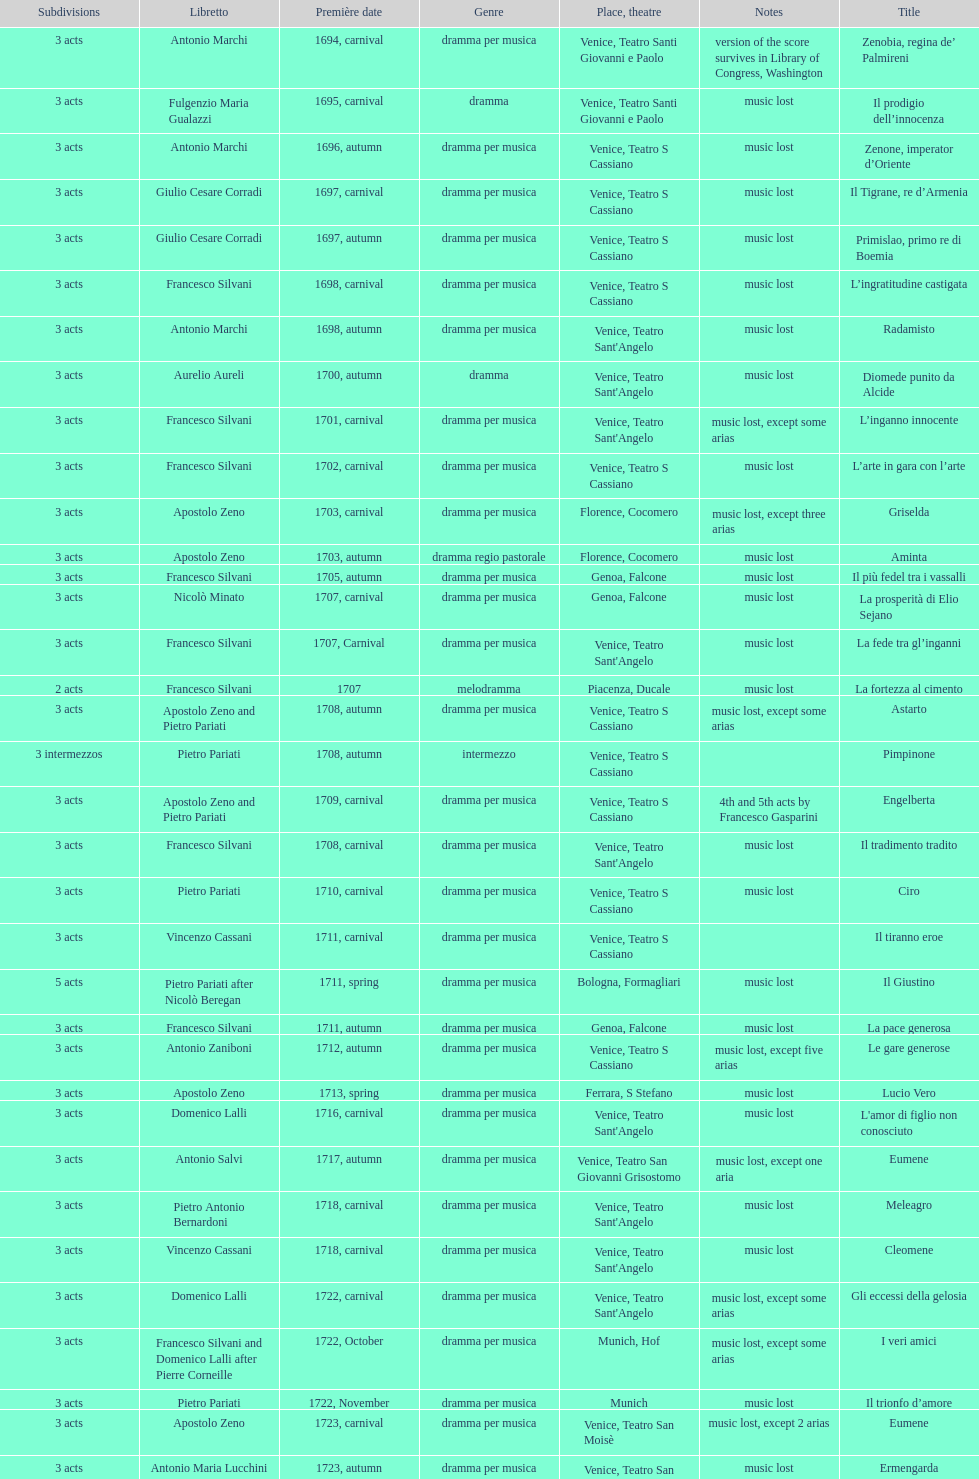Which was released earlier, artamene or merope? Merope. Parse the full table. {'header': ['Sub\xaddivisions', 'Libretto', 'Première date', 'Genre', 'Place, theatre', 'Notes', 'Title'], 'rows': [['3 acts', 'Antonio Marchi', '1694, carnival', 'dramma per musica', 'Venice, Teatro Santi Giovanni e Paolo', 'version of the score survives in Library of Congress, Washington', 'Zenobia, regina de’ Palmireni'], ['3 acts', 'Fulgenzio Maria Gualazzi', '1695, carnival', 'dramma', 'Venice, Teatro Santi Giovanni e Paolo', 'music lost', 'Il prodigio dell’innocenza'], ['3 acts', 'Antonio Marchi', '1696, autumn', 'dramma per musica', 'Venice, Teatro S Cassiano', 'music lost', 'Zenone, imperator d’Oriente'], ['3 acts', 'Giulio Cesare Corradi', '1697, carnival', 'dramma per musica', 'Venice, Teatro S Cassiano', 'music lost', 'Il Tigrane, re d’Armenia'], ['3 acts', 'Giulio Cesare Corradi', '1697, autumn', 'dramma per musica', 'Venice, Teatro S Cassiano', 'music lost', 'Primislao, primo re di Boemia'], ['3 acts', 'Francesco Silvani', '1698, carnival', 'dramma per musica', 'Venice, Teatro S Cassiano', 'music lost', 'L’ingratitudine castigata'], ['3 acts', 'Antonio Marchi', '1698, autumn', 'dramma per musica', "Venice, Teatro Sant'Angelo", 'music lost', 'Radamisto'], ['3 acts', 'Aurelio Aureli', '1700, autumn', 'dramma', "Venice, Teatro Sant'Angelo", 'music lost', 'Diomede punito da Alcide'], ['3 acts', 'Francesco Silvani', '1701, carnival', 'dramma per musica', "Venice, Teatro Sant'Angelo", 'music lost, except some arias', 'L’inganno innocente'], ['3 acts', 'Francesco Silvani', '1702, carnival', 'dramma per musica', 'Venice, Teatro S Cassiano', 'music lost', 'L’arte in gara con l’arte'], ['3 acts', 'Apostolo Zeno', '1703, carnival', 'dramma per musica', 'Florence, Cocomero', 'music lost, except three arias', 'Griselda'], ['3 acts', 'Apostolo Zeno', '1703, autumn', 'dramma regio pastorale', 'Florence, Cocomero', 'music lost', 'Aminta'], ['3 acts', 'Francesco Silvani', '1705, autumn', 'dramma per musica', 'Genoa, Falcone', 'music lost', 'Il più fedel tra i vassalli'], ['3 acts', 'Nicolò Minato', '1707, carnival', 'dramma per musica', 'Genoa, Falcone', 'music lost', 'La prosperità di Elio Sejano'], ['3 acts', 'Francesco Silvani', '1707, Carnival', 'dramma per musica', "Venice, Teatro Sant'Angelo", 'music lost', 'La fede tra gl’inganni'], ['2 acts', 'Francesco Silvani', '1707', 'melodramma', 'Piacenza, Ducale', 'music lost', 'La fortezza al cimento'], ['3 acts', 'Apostolo Zeno and Pietro Pariati', '1708, autumn', 'dramma per musica', 'Venice, Teatro S Cassiano', 'music lost, except some arias', 'Astarto'], ['3 intermezzos', 'Pietro Pariati', '1708, autumn', 'intermezzo', 'Venice, Teatro S Cassiano', '', 'Pimpinone'], ['3 acts', 'Apostolo Zeno and Pietro Pariati', '1709, carnival', 'dramma per musica', 'Venice, Teatro S Cassiano', '4th and 5th acts by Francesco Gasparini', 'Engelberta'], ['3 acts', 'Francesco Silvani', '1708, carnival', 'dramma per musica', "Venice, Teatro Sant'Angelo", 'music lost', 'Il tradimento tradito'], ['3 acts', 'Pietro Pariati', '1710, carnival', 'dramma per musica', 'Venice, Teatro S Cassiano', 'music lost', 'Ciro'], ['3 acts', 'Vincenzo Cassani', '1711, carnival', 'dramma per musica', 'Venice, Teatro S Cassiano', '', 'Il tiranno eroe'], ['5 acts', 'Pietro Pariati after Nicolò Beregan', '1711, spring', 'dramma per musica', 'Bologna, Formagliari', 'music lost', 'Il Giustino'], ['3 acts', 'Francesco Silvani', '1711, autumn', 'dramma per musica', 'Genoa, Falcone', 'music lost', 'La pace generosa'], ['3 acts', 'Antonio Zaniboni', '1712, autumn', 'dramma per musica', 'Venice, Teatro S Cassiano', 'music lost, except five arias', 'Le gare generose'], ['3 acts', 'Apostolo Zeno', '1713, spring', 'dramma per musica', 'Ferrara, S Stefano', 'music lost', 'Lucio Vero'], ['3 acts', 'Domenico Lalli', '1716, carnival', 'dramma per musica', "Venice, Teatro Sant'Angelo", 'music lost', "L'amor di figlio non conosciuto"], ['3 acts', 'Antonio Salvi', '1717, autumn', 'dramma per musica', 'Venice, Teatro San Giovanni Grisostomo', 'music lost, except one aria', 'Eumene'], ['3 acts', 'Pietro Antonio Bernardoni', '1718, carnival', 'dramma per musica', "Venice, Teatro Sant'Angelo", 'music lost', 'Meleagro'], ['3 acts', 'Vincenzo Cassani', '1718, carnival', 'dramma per musica', "Venice, Teatro Sant'Angelo", 'music lost', 'Cleomene'], ['3 acts', 'Domenico Lalli', '1722, carnival', 'dramma per musica', "Venice, Teatro Sant'Angelo", 'music lost, except some arias', 'Gli eccessi della gelosia'], ['3 acts', 'Francesco Silvani and Domenico Lalli after Pierre Corneille', '1722, October', 'dramma per musica', 'Munich, Hof', 'music lost, except some arias', 'I veri amici'], ['3 acts', 'Pietro Pariati', '1722, November', 'dramma per musica', 'Munich', 'music lost', 'Il trionfo d’amore'], ['3 acts', 'Apostolo Zeno', '1723, carnival', 'dramma per musica', 'Venice, Teatro San Moisè', 'music lost, except 2 arias', 'Eumene'], ['3 acts', 'Antonio Maria Lucchini', '1723, autumn', 'dramma per musica', 'Venice, Teatro San Moisè', 'music lost', 'Ermengarda'], ['5 acts', 'Giovanni Piazzon', '1724, carnival', 'tragedia', 'Venice, Teatro San Moisè', '5th act by Giovanni Porta, music lost', 'Antigono, tutore di Filippo, re di Macedonia'], ['3 acts', 'Apostolo Zeno', '1724, Ascension', 'dramma per musica', 'Venice, Teatro San Samuele', 'music lost', 'Scipione nelle Spagne'], ['3 acts', 'Angelo Schietti', '1724, autumn', 'dramma per musica', 'Venice, Teatro San Moisè', 'music lost, except 2 arias', 'Laodice'], ['3 acts', 'Metastasio', '1725, carnival', 'tragedia', 'Venice, Teatro S Cassiano', 'music lost', 'Didone abbandonata'], ['2 acts', 'Metastasio', '1725, carnival', 'intermezzo', 'Venice, Teatro S Cassiano', 'music lost', "L'impresario delle Isole Canarie"], ['3 acts', 'Antonio Marchi', '1725, autumn', 'dramma per musica', 'Venice, Teatro S Cassiano', 'music lost', 'Alcina delusa da Ruggero'], ['3 acts', 'Apostolo Zeno', '1725', 'dramma per musica', 'Brescia, Nuovo', '', 'I rivali generosi'], ['3 acts', 'Apostolo Zeno and Pietro Pariati', '1726, Carnival', 'dramma per musica', 'Rome, Teatro Capranica', '', 'La Statira'], ['', '', '1726, Carnival', 'intermezzo', 'Rome, Teatro Capranica', '', 'Malsazio e Fiammetta'], ['3 acts', 'Girolamo Colatelli after Torquato Tasso', '1726, autumn', 'dramma per musica', 'Venice, Teatro San Moisè', 'music lost', 'Il trionfo di Armida'], ['3 acts', 'Vincenzo Cassani', '1727, Ascension', 'dramma comico-pastorale', 'Venice, Teatro San Samuele', 'music lost, except some arias', 'L’incostanza schernita'], ['3 acts', 'Aurelio Aureli', '1728, autumn', 'dramma per musica', 'Venice, Teatro San Moisè', 'music lost', 'Le due rivali in amore'], ['', 'Salvi', '1729', 'intermezzo', 'Parma, Omodeo', '', 'Il Satrapone'], ['3 acts', 'F Passerini', '1730, carnival', 'dramma per musica', 'Venice, Teatro San Moisè', 'music lost', 'Li stratagemmi amorosi'], ['3 acts', 'Luisa Bergalli', '1730, carnival', 'dramma per musica', "Venice, Teatro Sant'Angelo", 'music lost', 'Elenia'], ['3 acts', 'Apostolo Zeno', '1731, autumn', 'dramma', 'Prague, Sporck Theater', 'mostly by Albinoni, music lost', 'Merope'], ['3 acts', 'Angelo Schietti', '1731, autumn', 'dramma per musica', 'Treviso, Dolphin', 'music lost', 'Il più infedel tra gli amanti'], ['3 acts', 'Bartolomeo Vitturi', '1732, autumn', 'dramma', "Venice, Teatro Sant'Angelo", 'music lost, except five arias', 'Ardelinda'], ['3 acts', 'Bartolomeo Vitturi', '1734, carnival', 'dramma per musica', "Venice, Teatro Sant'Angelo", 'music lost', 'Candalide'], ['3 acts', 'Bartolomeo Vitturi', '1741, carnival', 'dramma per musica', "Venice, Teatro Sant'Angelo", 'music lost', 'Artamene']]} 